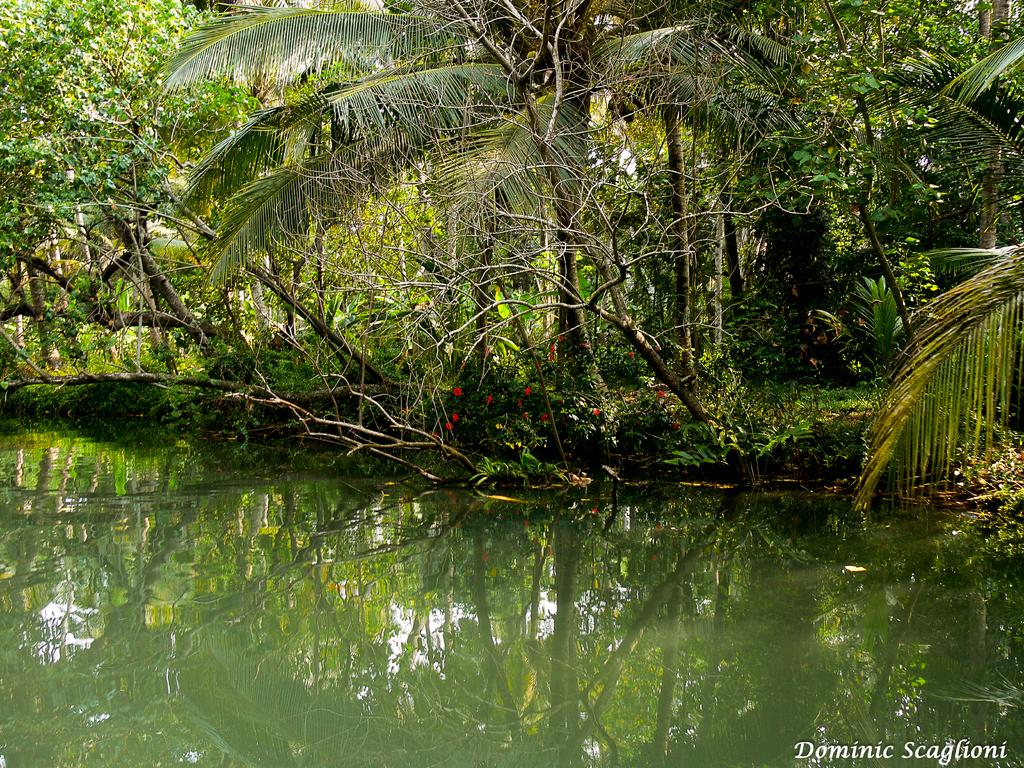What type of vegetation can be seen in the image? There are trees, plants, and flowers in the image. What is visible at the bottom of the image? There is water visible at the bottom of the image. What else can be found in the image besides vegetation and water? There is text present in the image. What type of chalk is being used to draw on the flowers in the image? There is no chalk or drawing activity present in the image; it features trees, plants, flowers, water, and text. 